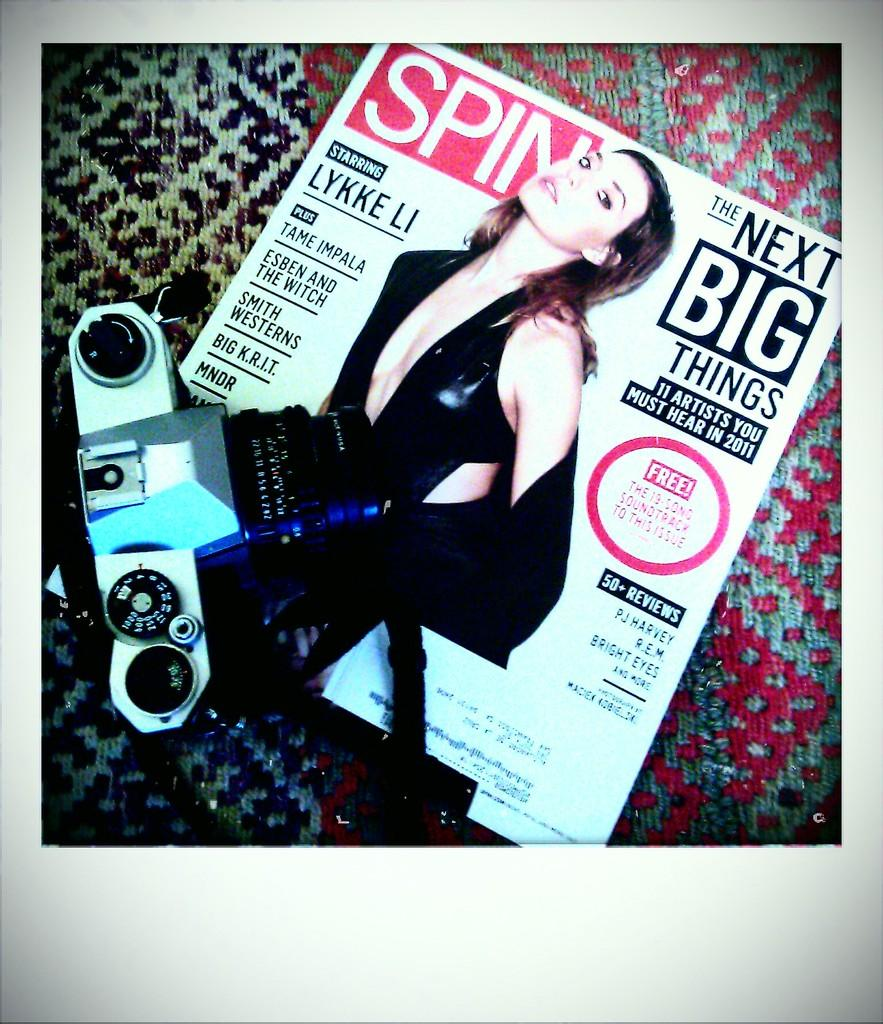What object can be seen in the image that is used for capturing photos? There is a camera in the image. What type of decoration or advertisement is present in the image? There is a poster in the image. What type of flooring is visible at the bottom of the image? There is a carpet at the bottom of the image. What type of pancake is being served on the sidewalk in the image? There is no pancake or sidewalk present in the image. How many visitors can be seen in the image? There is no visitor present in the image. 